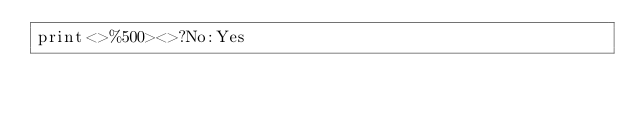Convert code to text. <code><loc_0><loc_0><loc_500><loc_500><_Perl_>print<>%500><>?No:Yes</code> 